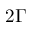<formula> <loc_0><loc_0><loc_500><loc_500>2 \Gamma</formula> 